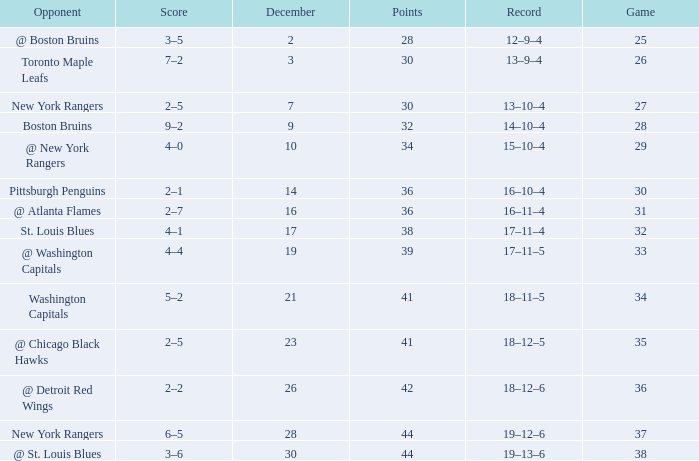Which Game has a Record of 14–10–4, and Points smaller than 32? None. 